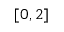<formula> <loc_0><loc_0><loc_500><loc_500>[ 0 , 2 ]</formula> 